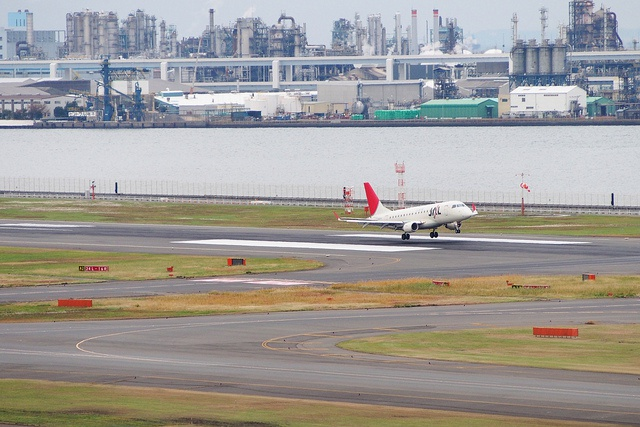Describe the objects in this image and their specific colors. I can see a airplane in lightgray, darkgray, gray, and black tones in this image. 